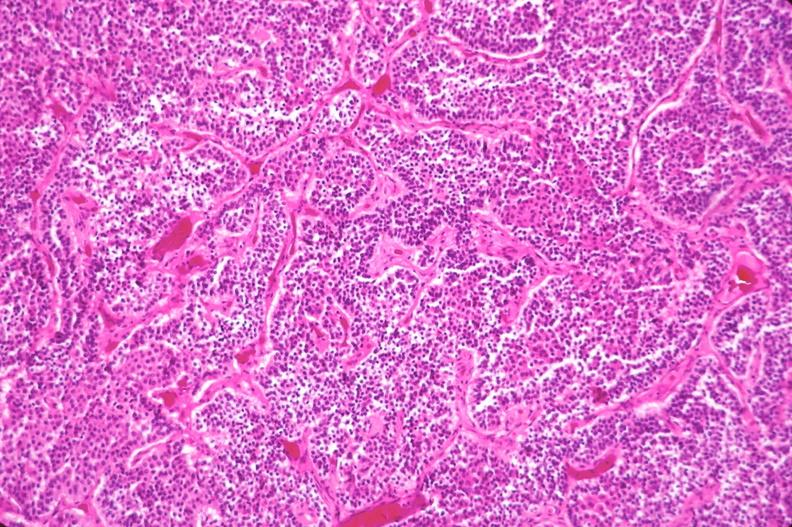does fixed tissue show pituitary, chromaphobe adenoma?
Answer the question using a single word or phrase. No 